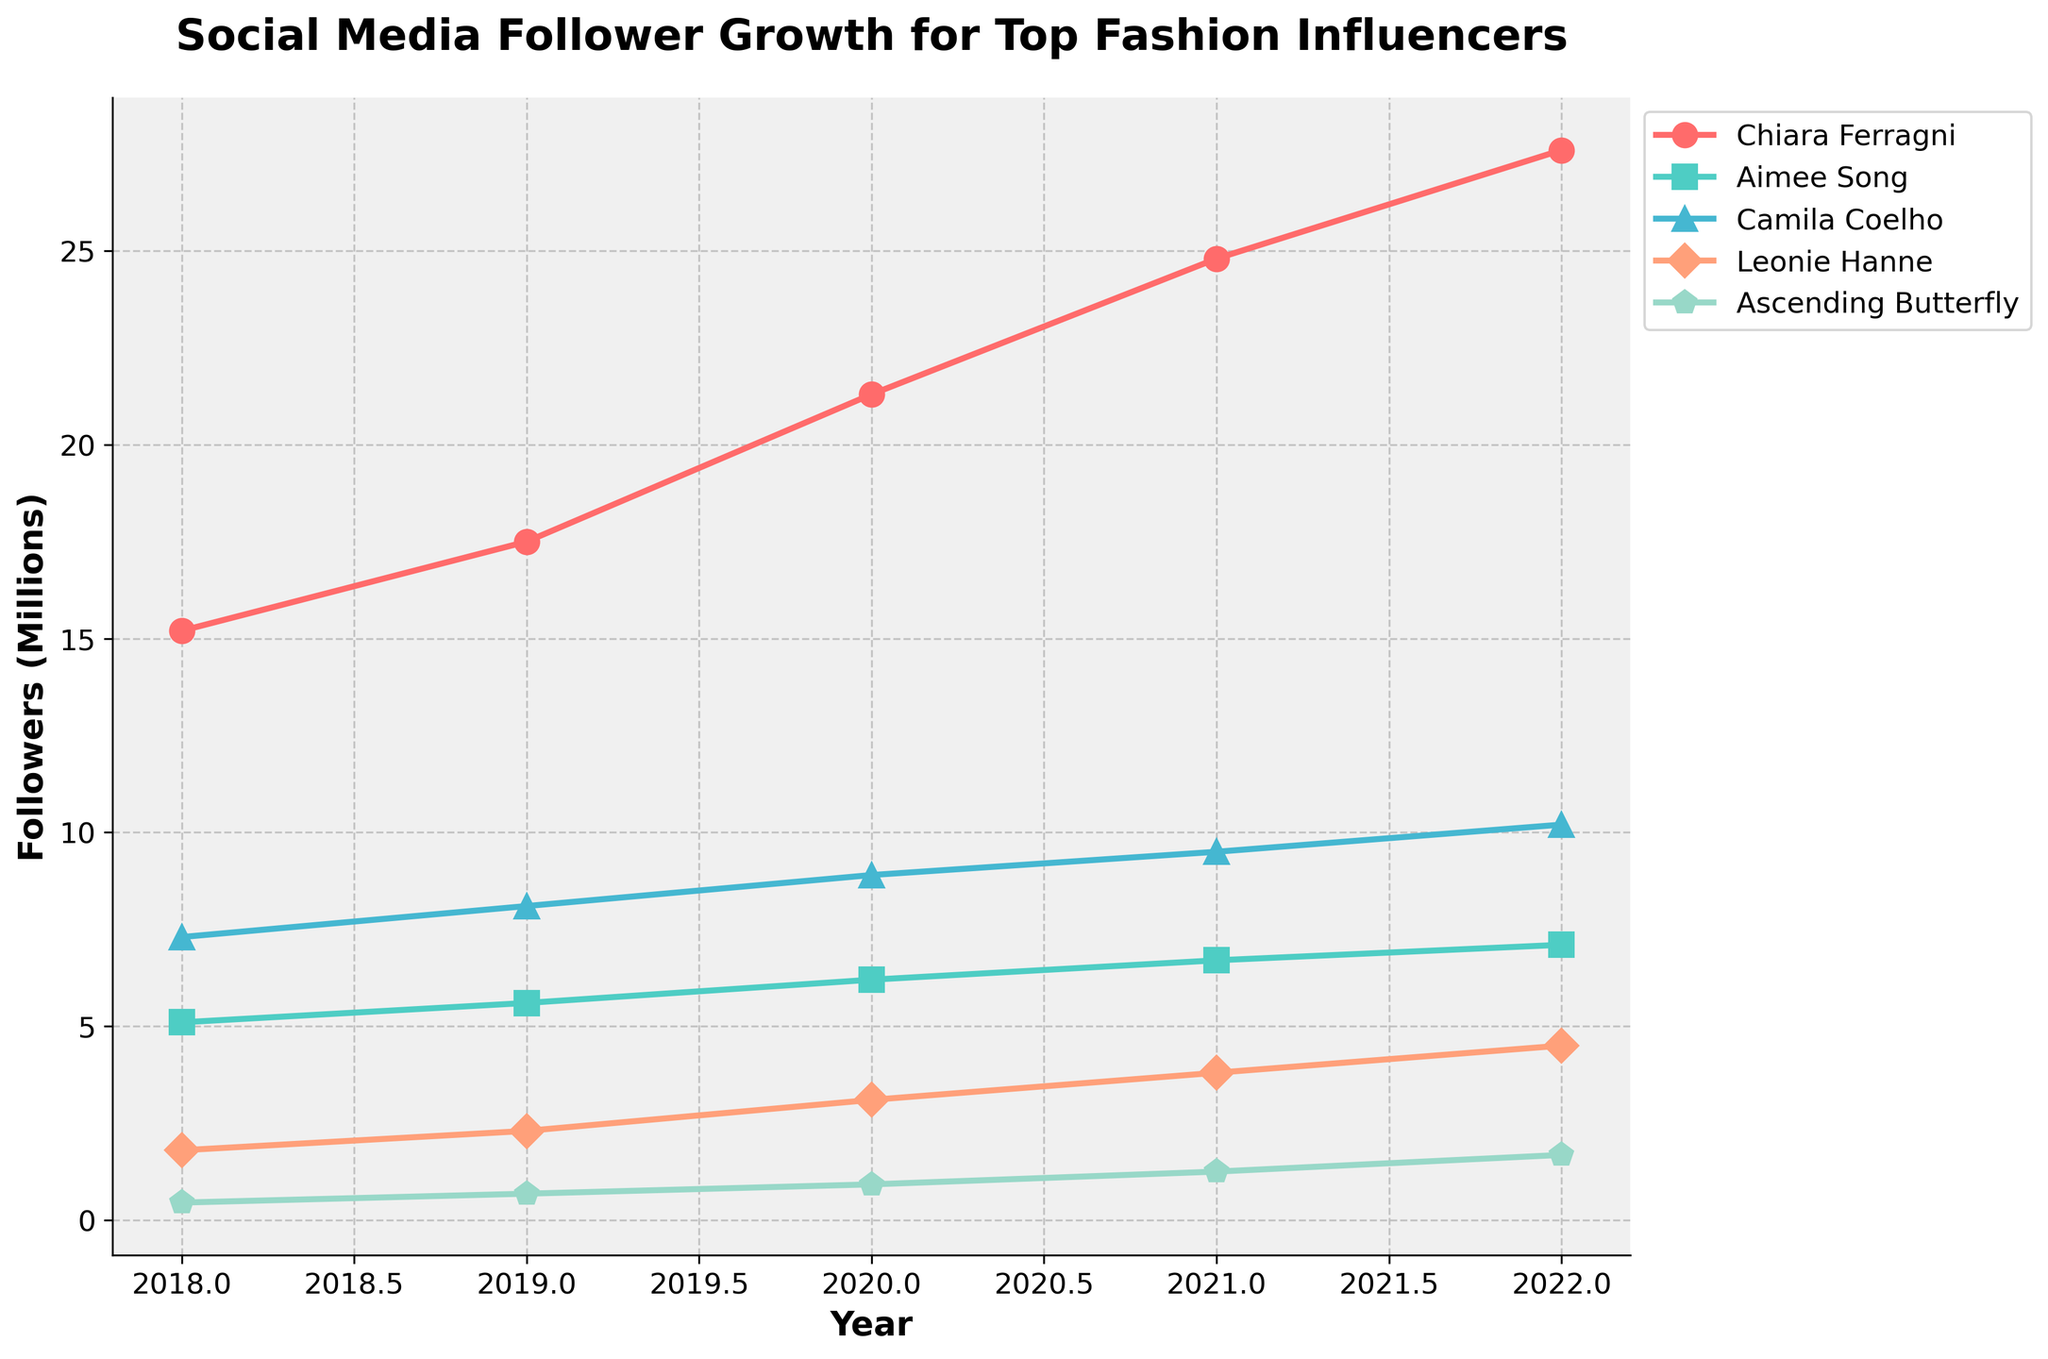Which influencer saw the largest increase in followers from 2021 to 2022? To determine the largest increase, find the difference between 2021 and 2022 followers for each influencer and then compare. 
- Chiara Ferragni: 27600000 - 24800000 = 2800000 
- Aimee Song: 7100000 - 6700000 = 400000 
- Camila Coelho: 10200000 - 9500000 = 700000 
- Leonie Hanne: 4500000 - 3800000 = 700000 
- Ascending Butterfly: 1680000 - 1250000 = 430000 
The largest increase is for Chiara Ferragni with 2800000.
Answer: Chiara Ferragni How many influencers had more than 10 million followers in 2022? Identify the follower count of each influencer in 2022 and count how many exceeded 10 million. 
- Chiara Ferragni: 27600000 
- Aimee Song: 7100000 
- Camila Coelho: 10200000 
- Leonie Hanne: 4500000 
- Ascending Butterfly: 1680000 
Only Chiara Ferragni and Camila Coelho had more than 10 million followers in 2022.
Answer: 2 Which influencer had the smallest number of followers in 2020? Look at the follower counts for each influencer in 2020 and identify the smallest number.
- Chiara Ferragni: 21300000 
- Aimee Song: 6200000 
- Camila Coelho: 8900000 
- Leonie Hanne: 3100000 
- Ascending Butterfly: 920000 
Ascending Butterfly had the smallest number of followers in 2020.
Answer: Ascending Butterfly Between which two consecutive years did Aimee Song see the highest relative growth in followers? Calculate the relative growth for each year: (new value - old value) / old value. 
- 2018 to 2019: (5600000 - 5100000) / 5100000 ≈ 0.098 
- 2019 to 2020: (6200000 - 5600000) / 5600000 ≈ 0.107 
- 2020 to 2021: (6700000 - 6200000) / 6200000 ≈ 0.081 
- 2021 to 2022: (7100000 - 6700000) / 6700000 ≈ 0.060 
The highest relative growth occurred between 2019 and 2020.
Answer: 2019 to 2020 Which influencer showed a consistent increase in followers every year? Check the follower count for each influencer year by year to see if there is a consistent increase.
- Chiara Ferragni: 15200000, 17500000, 21300000, 24800000, 27600000 
- Aimee Song: 5100000, 5600000, 6200000, 6700000, 7100000 
- Camila Coelho: 7300000, 8100000, 8900000, 9500000, 10200000 
- Leonie Hanne: 1800000, 2300000, 3100000, 3800000, 4500000 
- Ascending Butterfly: 450000, 680000, 920000, 1250000, 1680000 
All influencers showed a consistent increase every year.
Answer: All influencers In 2022, how do the followers of Ascending Butterfly compare to Aimee Song's followers in 2018? Ascending Butterfly had 1680000 followers in 2022, and Aimee Song had 5100000 followers in 2018. Compare these two numbers.
1680000 is much smaller compared to 5100000.
Answer: smaller What is the average number of followers for Chiara Ferragni over the five years? Sum Chiara Ferragni's followers for the five years and divide by 5.
(15200000 + 17500000 + 21300000 + 24800000 + 27600000) / 5 = (106700000) / 5 = 21340000
Answer: 21340000 By how much did Leonie Hanne's follower count increase from 2019 to 2021? Calculate the difference between Leonie Hanne's followers in 2021 and 2019.
3800000 - 2300000 = 1500000
Answer: 1500000 